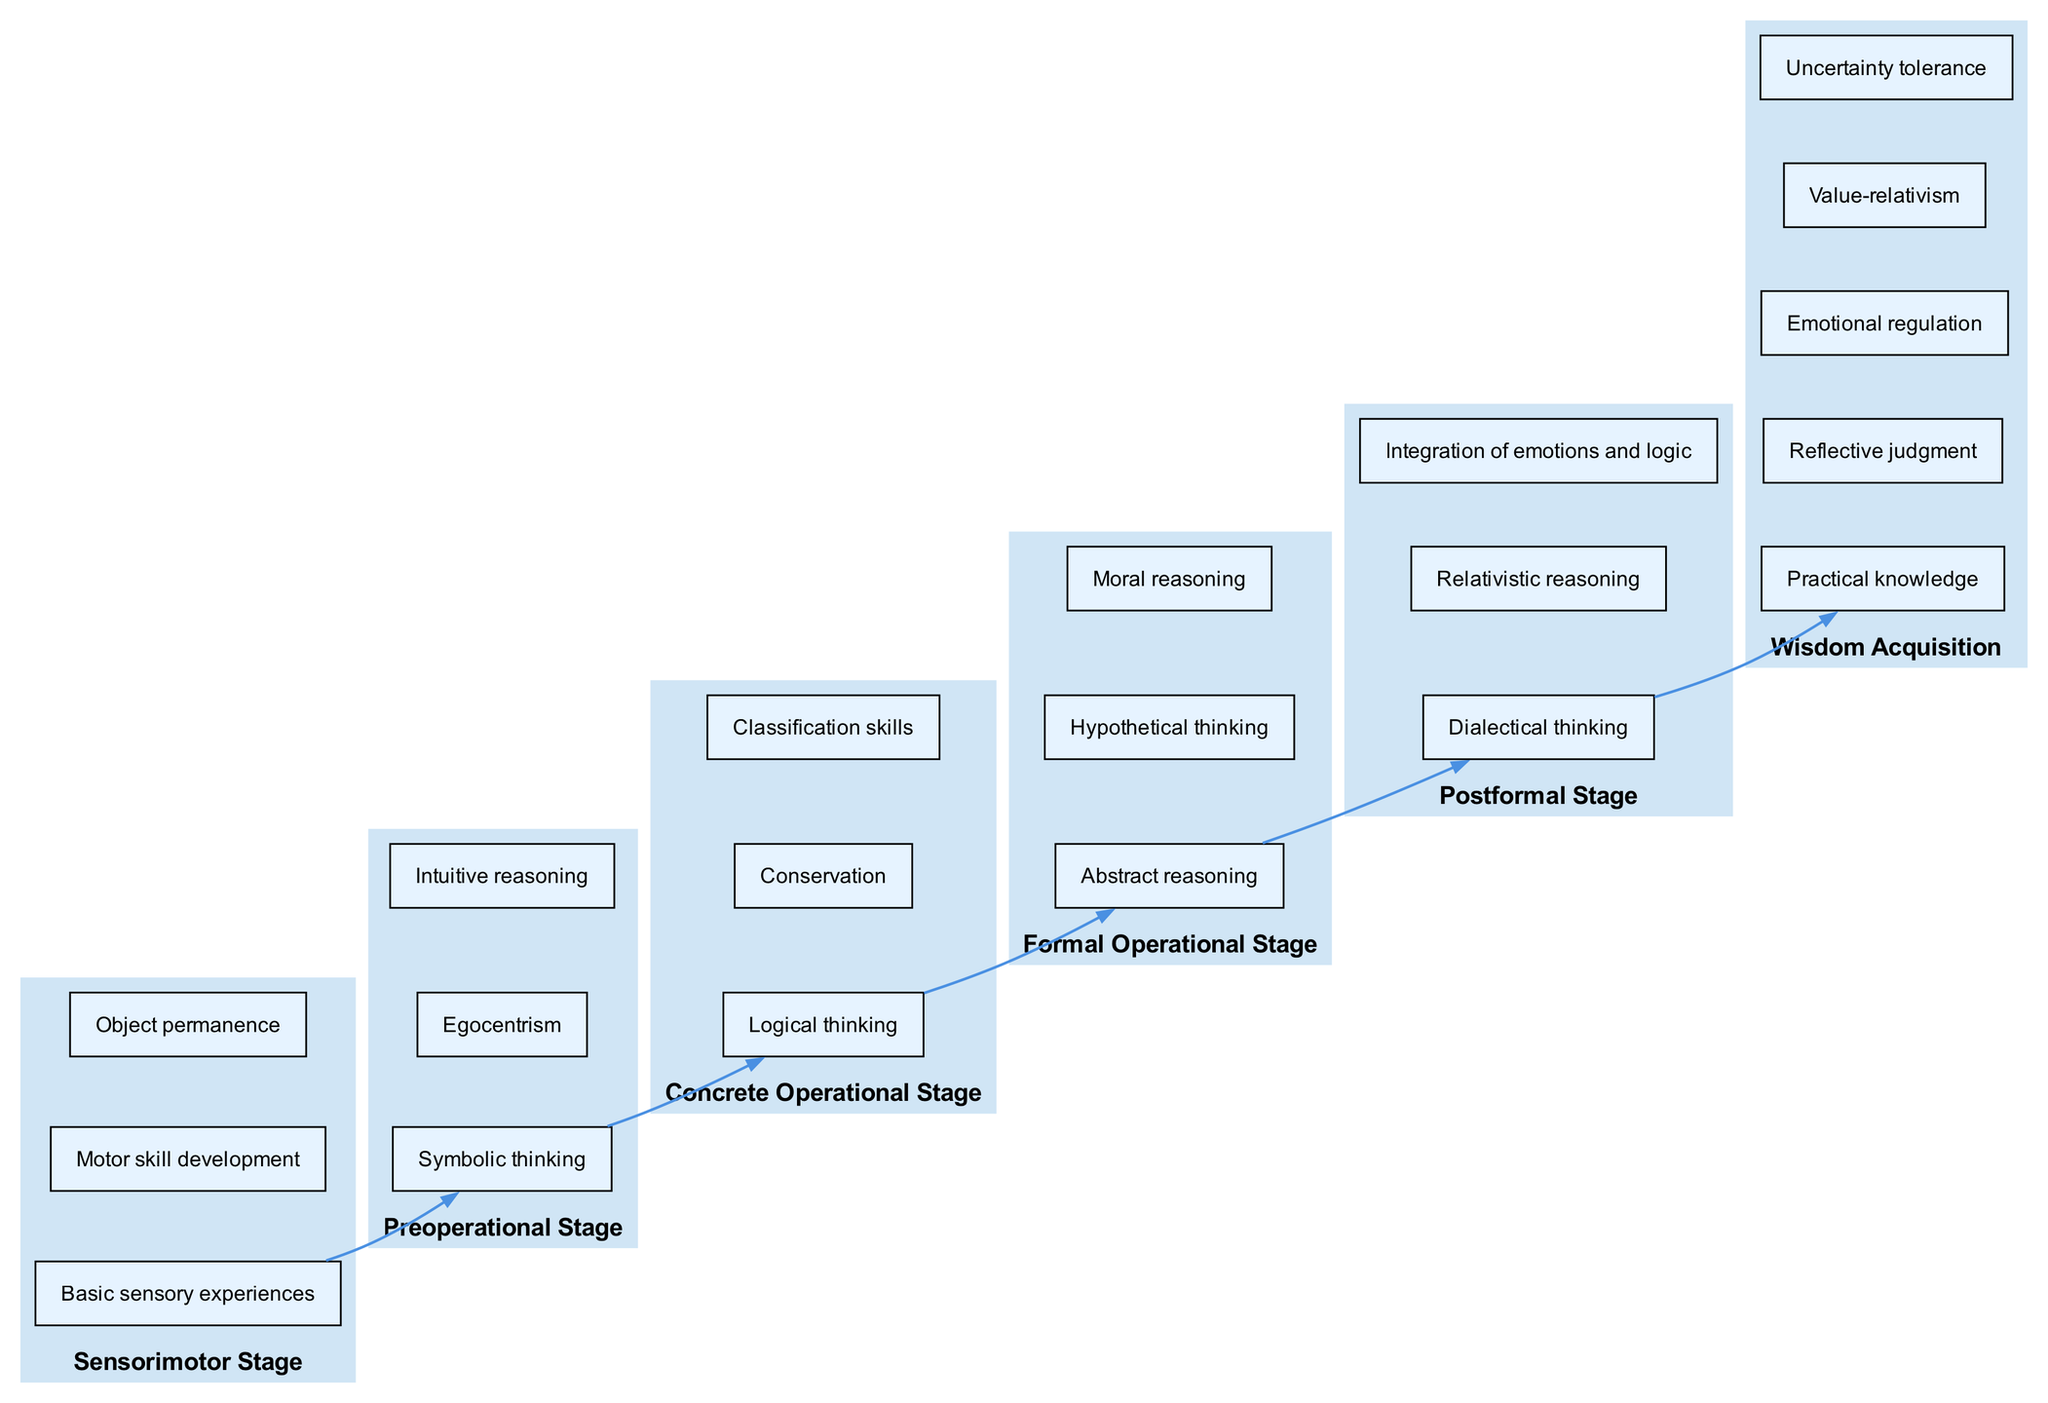What is the first stage in cognitive development? The diagram lists the stages in a bottom-up manner, starting with the "Sensorimotor Stage" at the bottom as the initial stage of cognitive development.
Answer: Sensorimotor Stage How many elements are in the Formal Operational Stage? Looking at the "Formal Operational Stage" in the diagram, I can see that it contains three elements: "Abstract reasoning," "Hypothetical thinking," and "Moral reasoning."
Answer: 3 Which cognitive stage focuses on egocentrism? The diagram shows that "Egocentrism" is one of the key elements in the "Preoperational Stage," indicating that this is where it is most emphasized.
Answer: Preoperational Stage What is the last stage before Wisdom Acquisition? The diagram illustrates that the "Postformal Stage" directly connects to "Wisdom Acquisition," making it the last stage before the attainment of wisdom.
Answer: Postformal Stage How many total stages are presented in the diagram? By counting the distinct stages listed in the diagram, I find there are a total of six stages, which are: Sensorimotor, Preoperational, Concrete Operational, Formal Operational, Postformal, and Wisdon Acquisition.
Answer: 6 What type of reasoning is associated with the Postformal Stage? The diagram identifies "Dialectical thinking," "Relativistic reasoning," and "Integration of emotions and logic" as key elements of the "Postformal Stage," indicating these are the types of reasoning developed at this stage.
Answer: Dialectical thinking Which stage involves symbolic thinking? The "Preoperational Stage" is where "Symbolic thinking" is specifically mentioned as one of its core elements, indicating its primary focus during this cognitive development phase.
Answer: Preoperational Stage What is the primary element under Wisdom Acquisition? The diagram outlines several elements of "Wisdom Acquisition," with "Practical knowledge" being one of the most significant, showing its importance in achieving wisdom.
Answer: Practical knowledge 